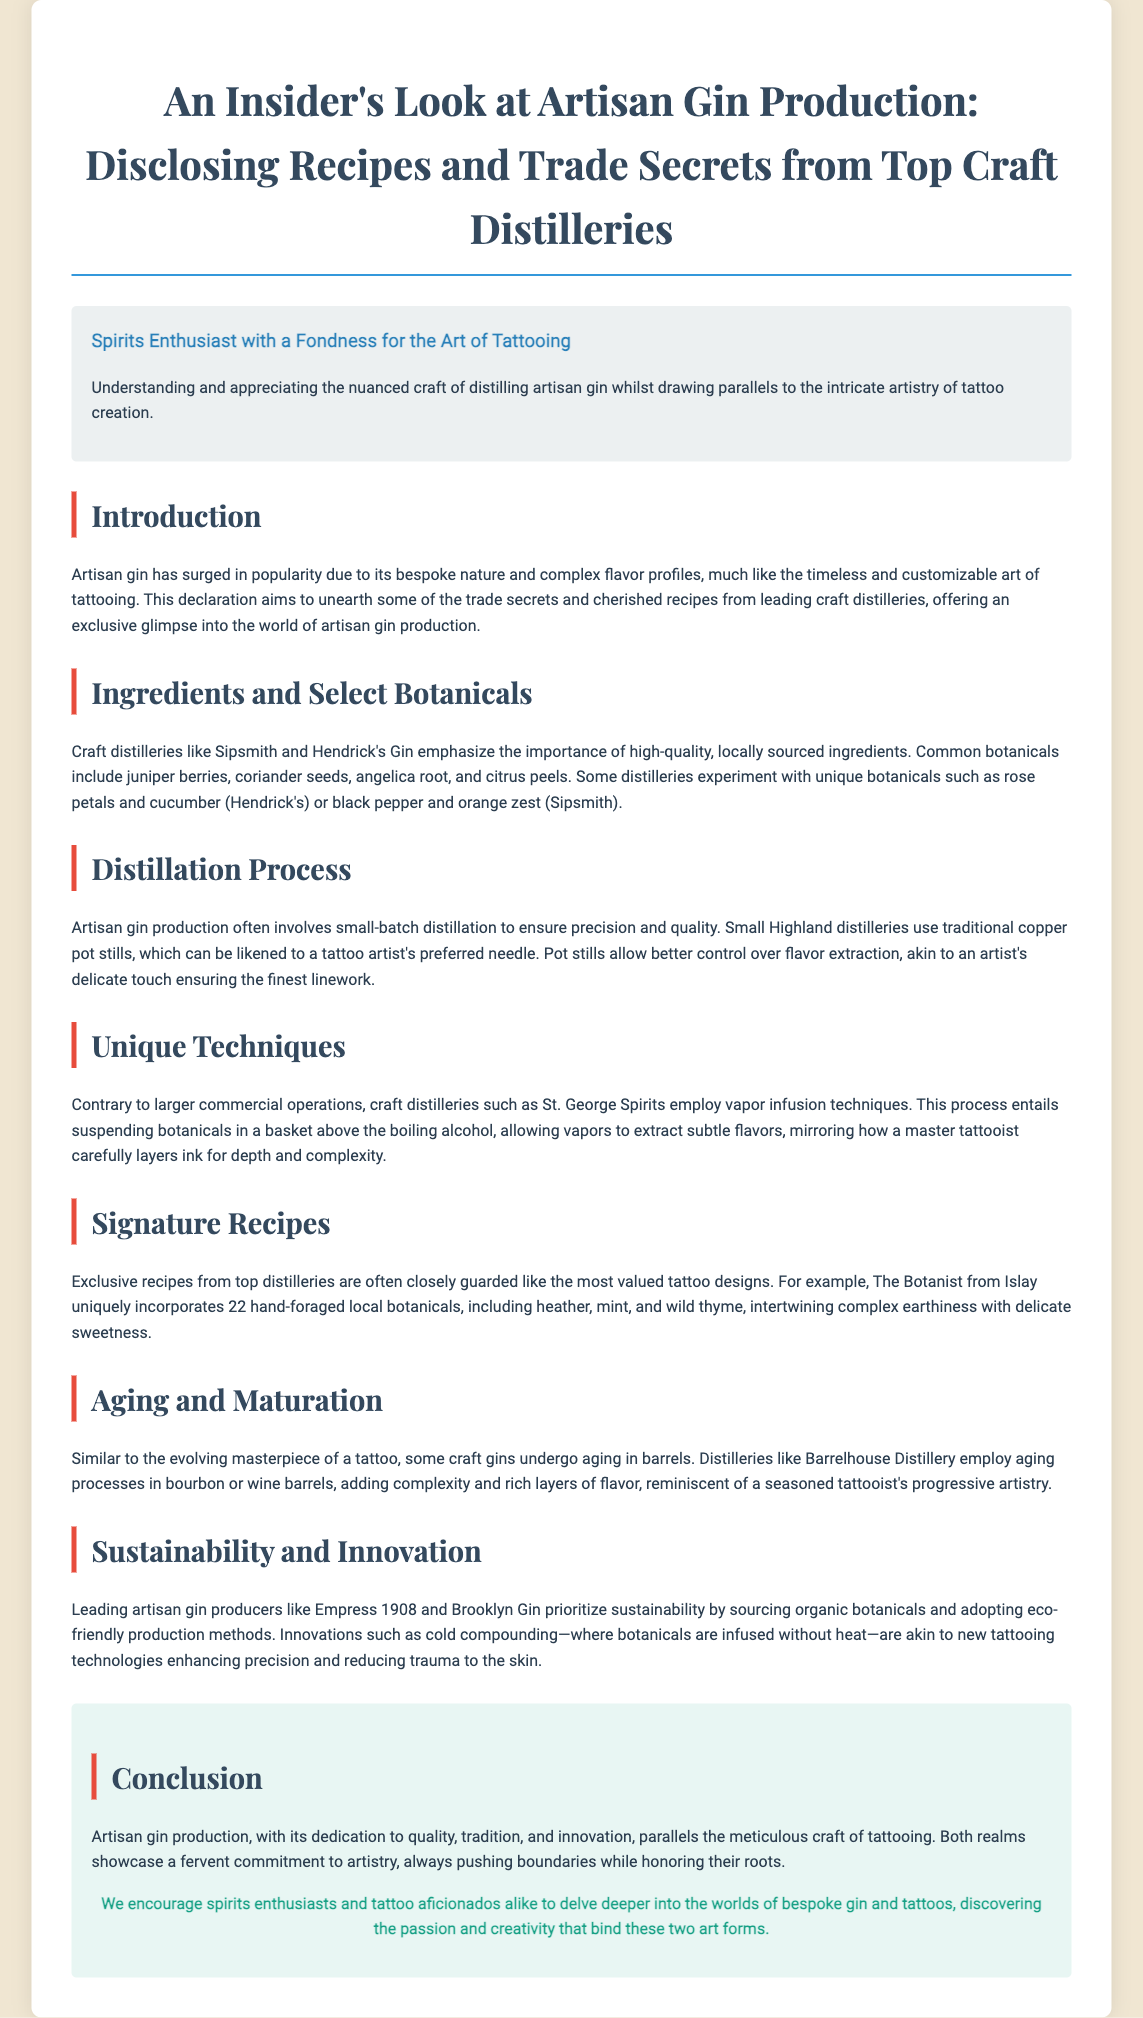What is artisan gin? Artisan gin is a category of gin noted for its bespoke nature and complex flavor profiles.
Answer: Bespoke nature and complex flavor profiles What do craft distilleries emphasize? Craft distilleries emphasize high-quality, locally sourced ingredients in their gin production.
Answer: High-quality, locally sourced ingredients Which distillery uniquely incorporates 22 botanicals? The Botanist from Islay uniquely incorporates 22 hand-foraged local botanicals, including heather, mint, and wild thyme.
Answer: The Botanist What technique do craft distilleries like St. George Spirits use? Craft distilleries like St. George Spirits employ vapor infusion techniques during distillation.
Answer: Vapor infusion techniques How many local botanicals does The Botanist include? The Botanist includes 22 hand-foraged local botanicals.
Answer: 22 What is similar about aging gin and tattooing? Aging gin in barrels is likened to the evolving masterpiece of a tattoo, both adding complexity and layers.
Answer: Evolving masterpiece What production method is prioritized by Empress 1908 and Brooklyn Gin? Empress 1908 and Brooklyn Gin prioritize sustainability by sourcing organic botanicals.
Answer: Sustainability What is the purpose of small-batch distillation? Small-batch distillation ensures precision and quality in artisan gin production.
Answer: Precision and quality What do both artisan gin production and tattooing showcase? Both showcase a fervent commitment to artistry and innovation while honoring their roots.
Answer: Commitment to artistry 